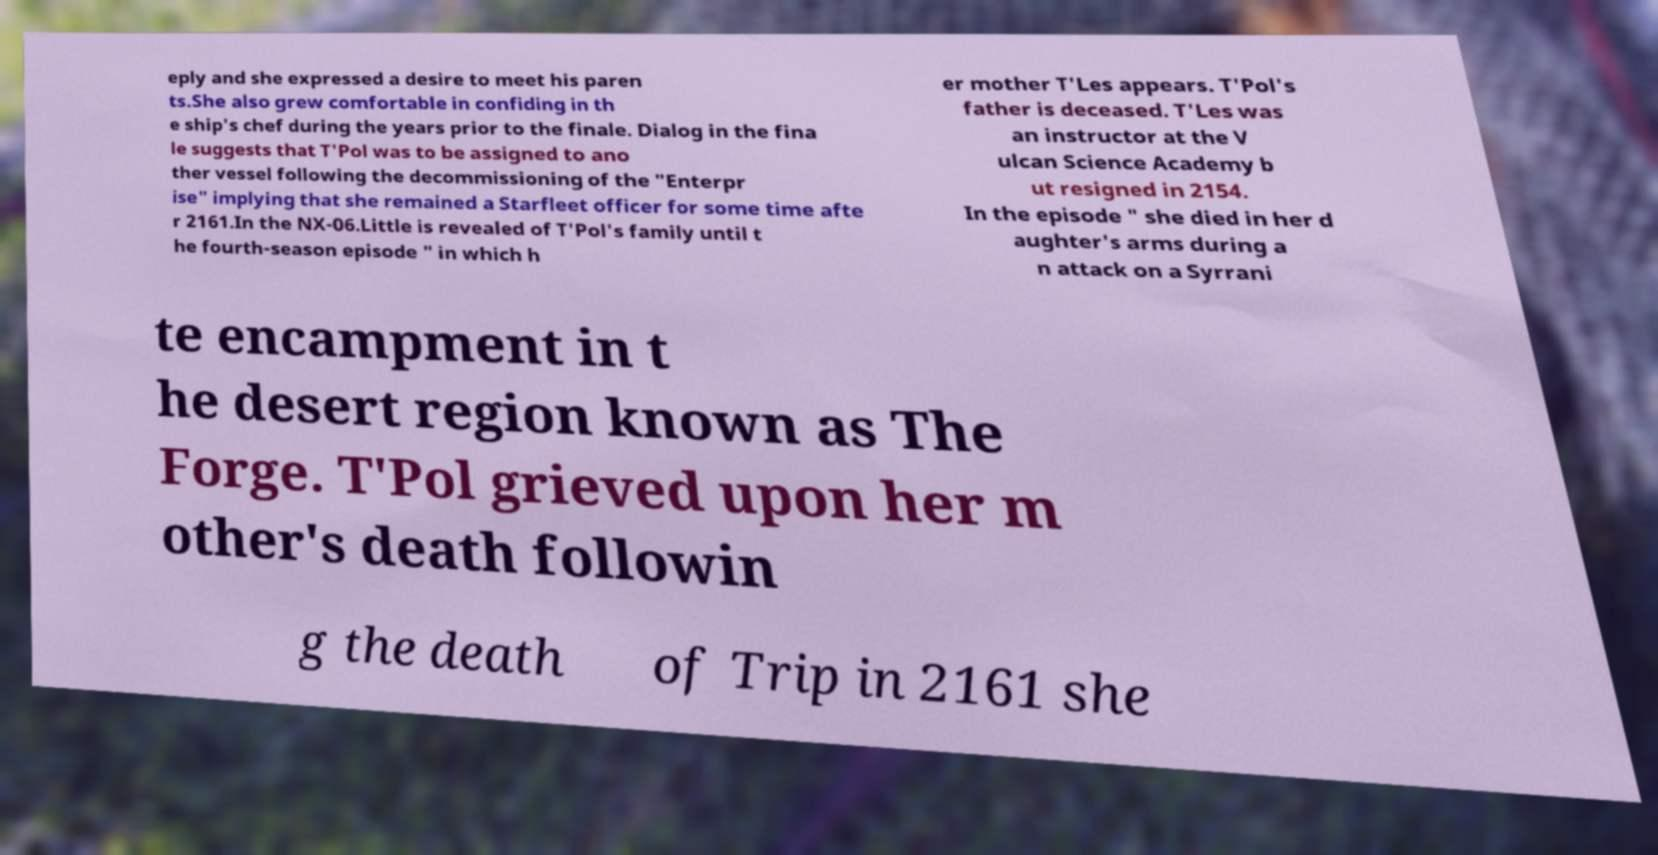I need the written content from this picture converted into text. Can you do that? eply and she expressed a desire to meet his paren ts.She also grew comfortable in confiding in th e ship's chef during the years prior to the finale. Dialog in the fina le suggests that T'Pol was to be assigned to ano ther vessel following the decommissioning of the "Enterpr ise" implying that she remained a Starfleet officer for some time afte r 2161.In the NX-06.Little is revealed of T'Pol's family until t he fourth-season episode " in which h er mother T'Les appears. T'Pol's father is deceased. T'Les was an instructor at the V ulcan Science Academy b ut resigned in 2154. In the episode " she died in her d aughter's arms during a n attack on a Syrrani te encampment in t he desert region known as The Forge. T'Pol grieved upon her m other's death followin g the death of Trip in 2161 she 